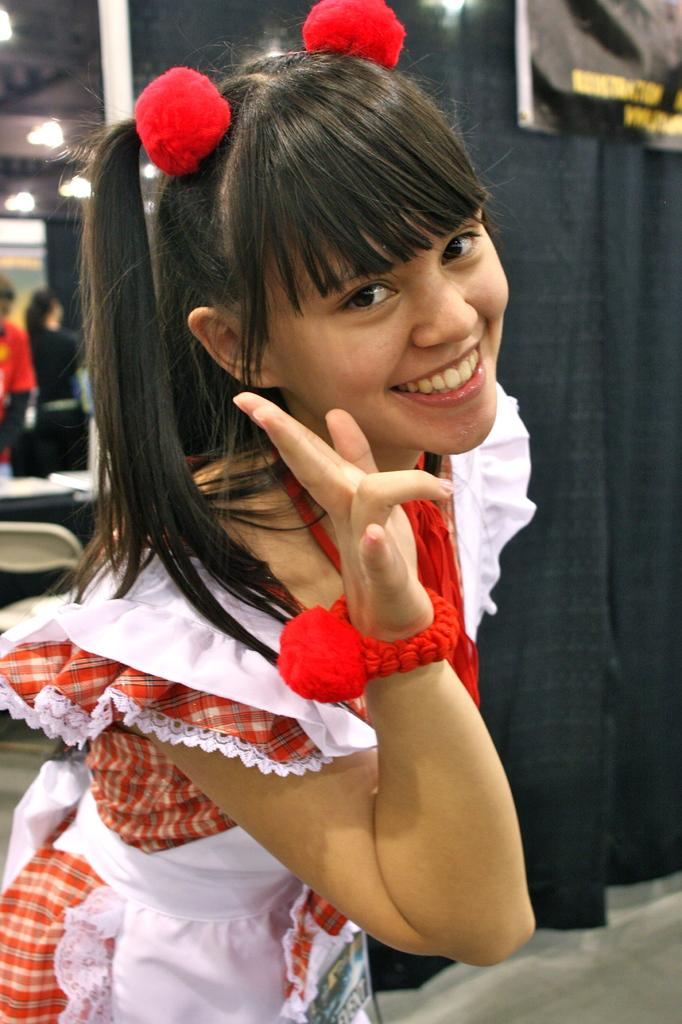Who is present in the image? There is a woman in the image. What is the woman doing in the image? The woman is smiling. What can be seen in the background of the image? There is a banner, cloth, a pole, a chair, people, lights, and other objects in the background of the image. How many legs does the spade have in the image? There is no spade present in the image. What date is marked on the calendar in the image? There is no calendar present in the image. 